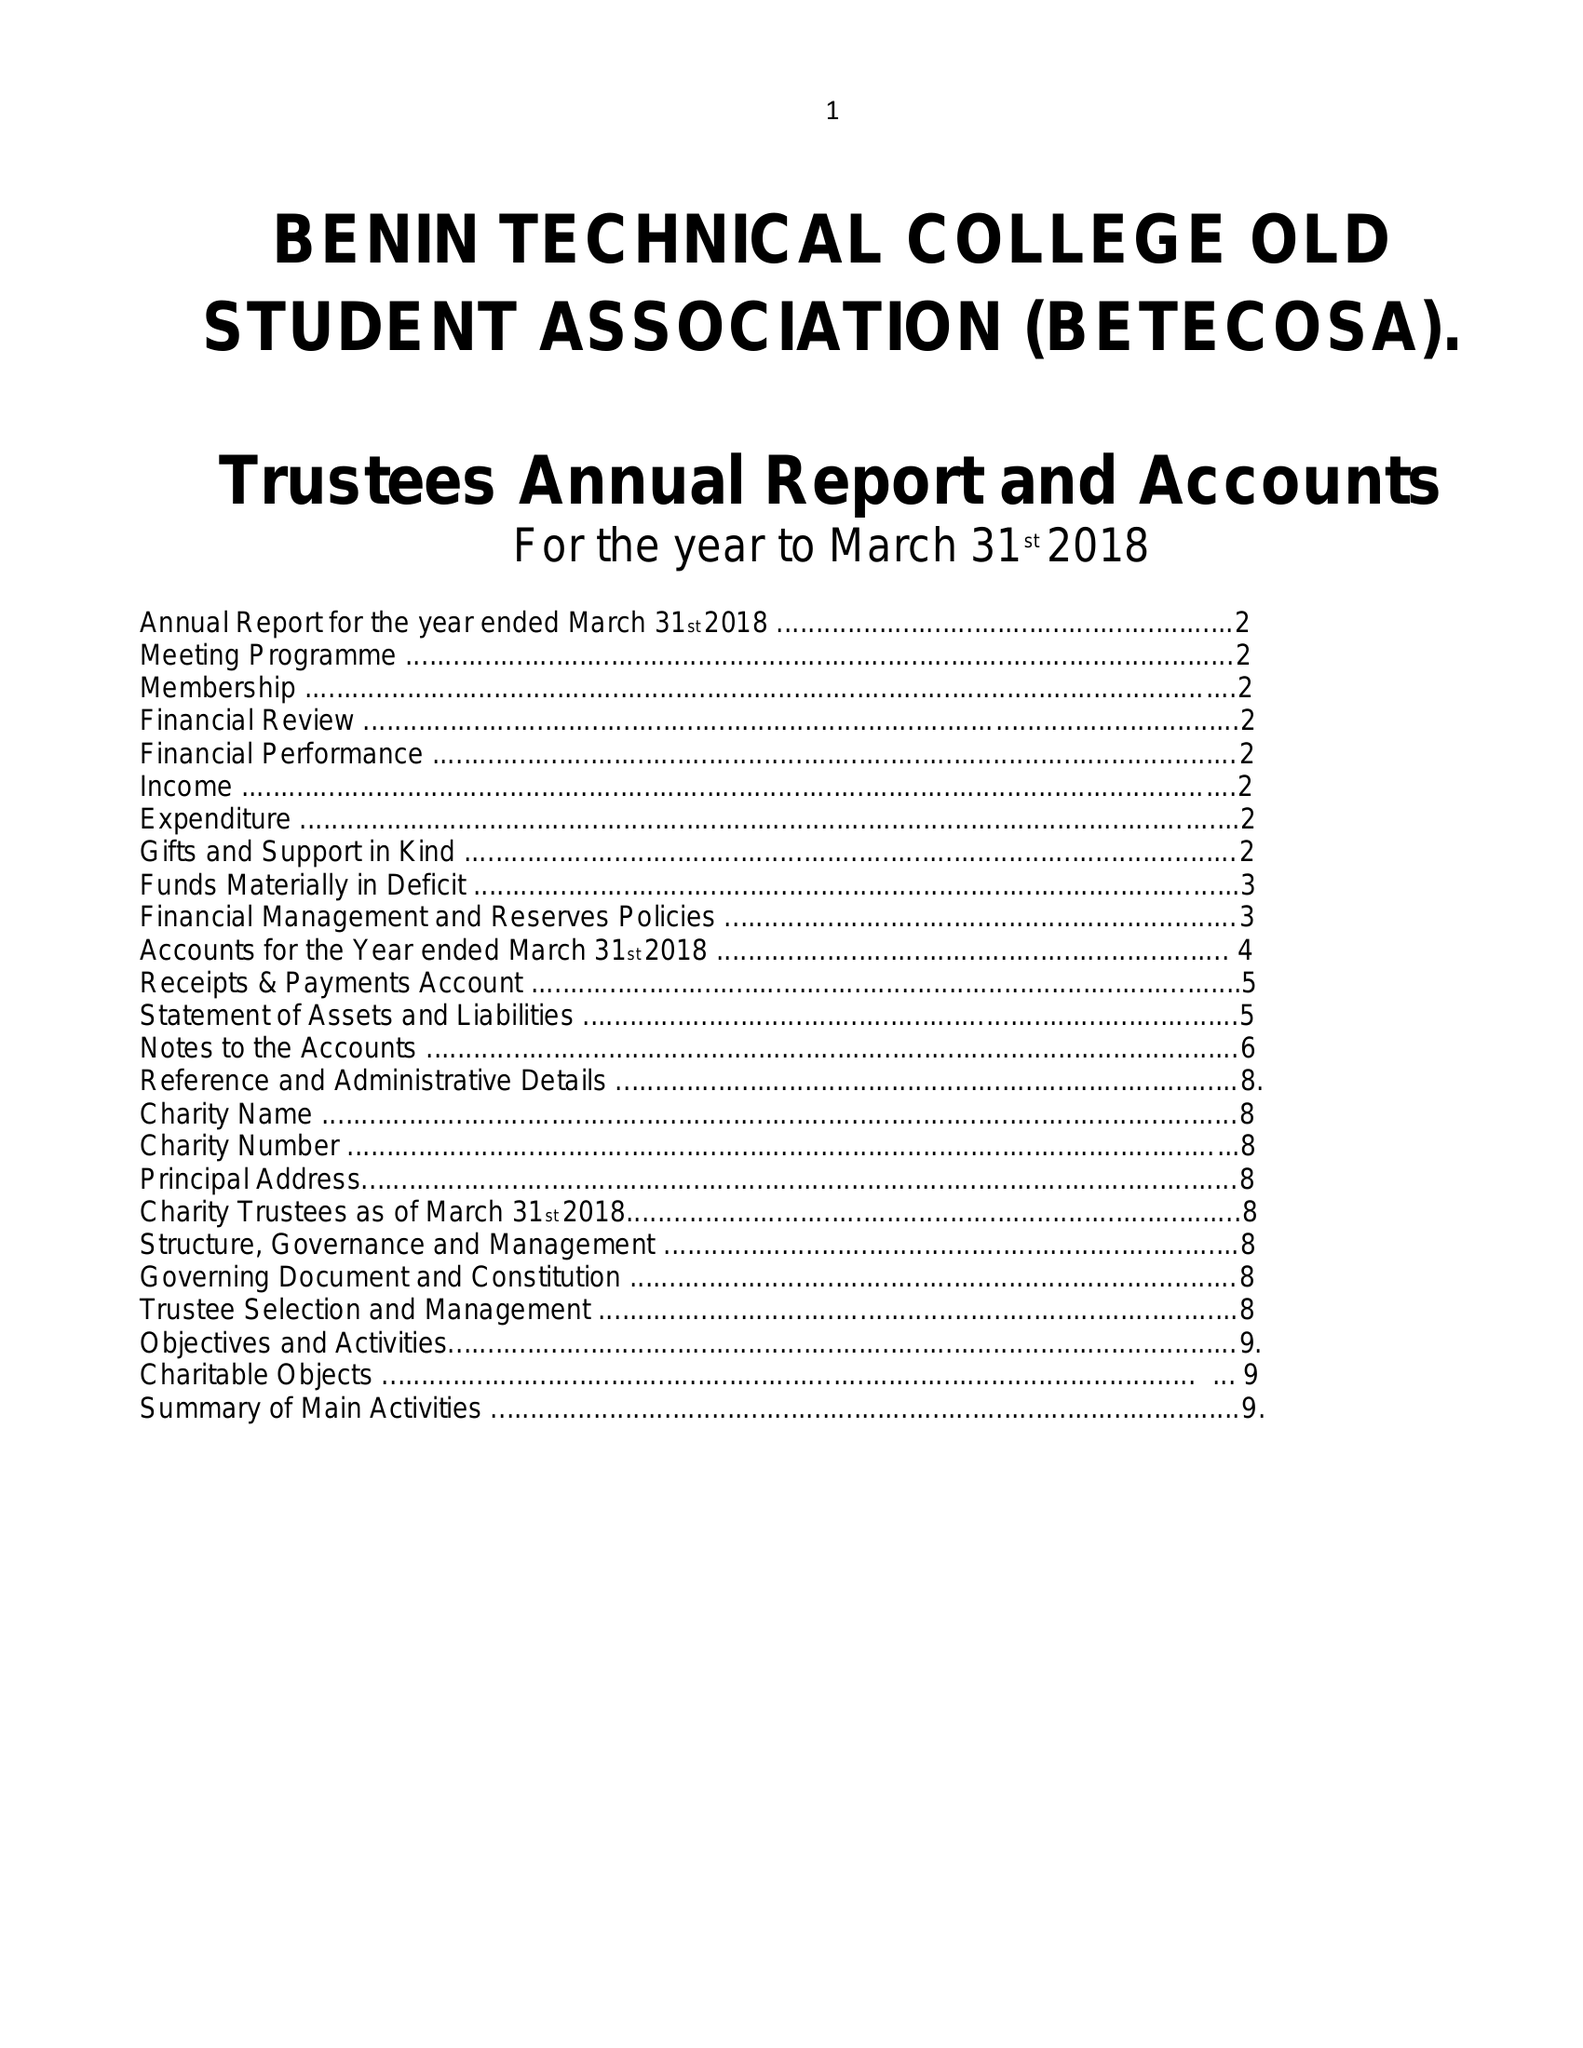What is the value for the address__post_town?
Answer the question using a single word or phrase. LONDON 